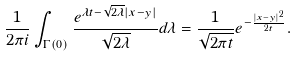Convert formula to latex. <formula><loc_0><loc_0><loc_500><loc_500>\frac { 1 } { 2 \pi i } \int _ { \Gamma ( 0 ) } \frac { e ^ { \lambda t - \sqrt { 2 \lambda } | x - y | } } { \sqrt { 2 \lambda } } d \lambda = \frac { 1 } { \sqrt { 2 \pi t } } e ^ { - \frac { | x - y | ^ { 2 } } { 2 t } } .</formula> 